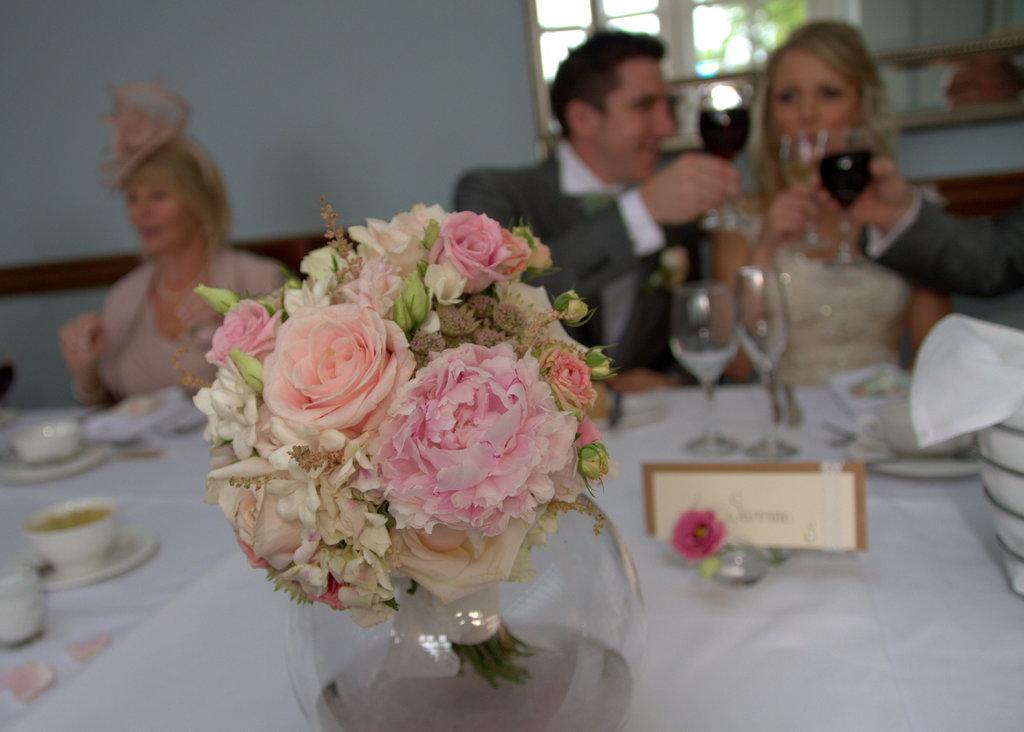Can you describe this image briefly? In this picture there are flowers kept on the table and they are person sitting there is food served in the plates and there are some wine glasses. 